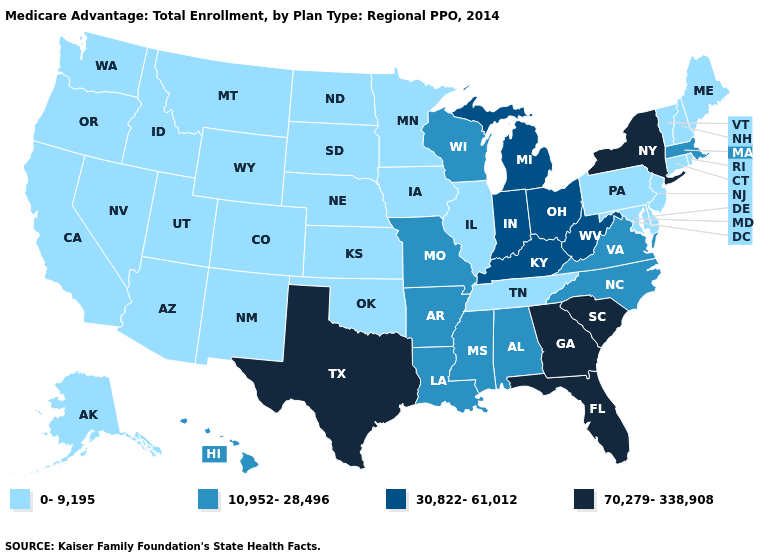What is the highest value in states that border Kentucky?
Be succinct. 30,822-61,012. Does the map have missing data?
Give a very brief answer. No. Among the states that border Rhode Island , does Massachusetts have the highest value?
Concise answer only. Yes. Does the map have missing data?
Keep it brief. No. Name the states that have a value in the range 10,952-28,496?
Answer briefly. Alabama, Arkansas, Hawaii, Louisiana, Massachusetts, Missouri, Mississippi, North Carolina, Virginia, Wisconsin. Does Indiana have the lowest value in the USA?
Answer briefly. No. Among the states that border Indiana , which have the highest value?
Give a very brief answer. Kentucky, Michigan, Ohio. Does the first symbol in the legend represent the smallest category?
Answer briefly. Yes. Does the first symbol in the legend represent the smallest category?
Give a very brief answer. Yes. What is the highest value in the USA?
Answer briefly. 70,279-338,908. Among the states that border Rhode Island , does Connecticut have the lowest value?
Answer briefly. Yes. What is the lowest value in the USA?
Concise answer only. 0-9,195. Name the states that have a value in the range 10,952-28,496?
Write a very short answer. Alabama, Arkansas, Hawaii, Louisiana, Massachusetts, Missouri, Mississippi, North Carolina, Virginia, Wisconsin. 